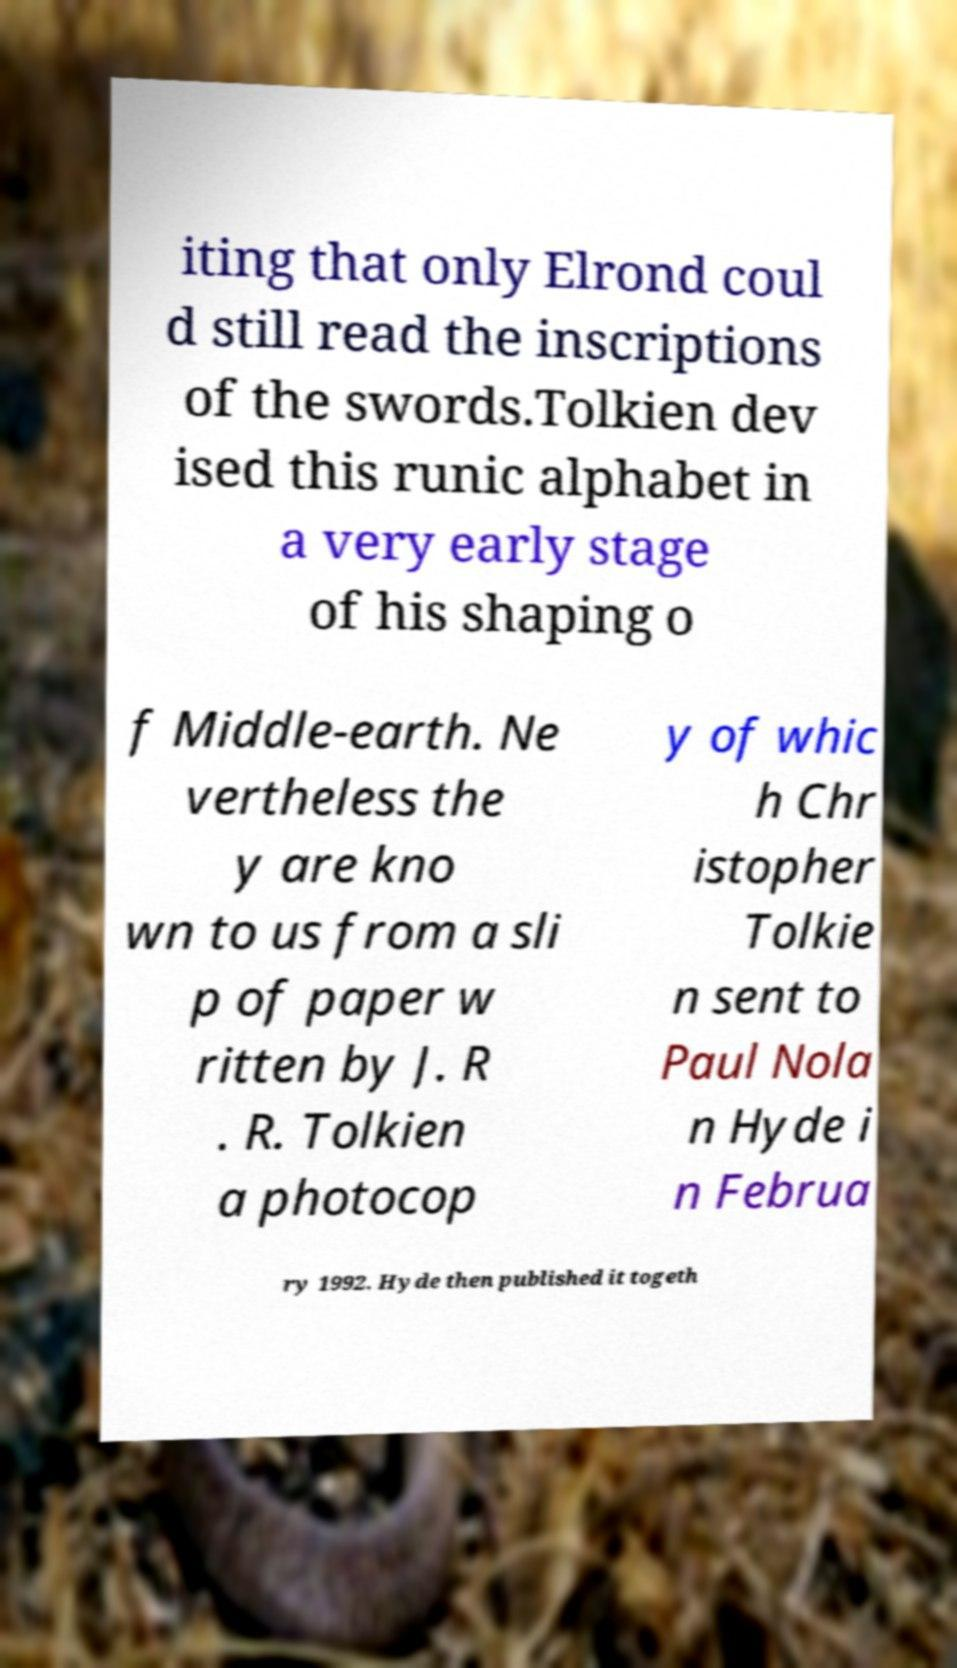Can you accurately transcribe the text from the provided image for me? iting that only Elrond coul d still read the inscriptions of the swords.Tolkien dev ised this runic alphabet in a very early stage of his shaping o f Middle-earth. Ne vertheless the y are kno wn to us from a sli p of paper w ritten by J. R . R. Tolkien a photocop y of whic h Chr istopher Tolkie n sent to Paul Nola n Hyde i n Februa ry 1992. Hyde then published it togeth 